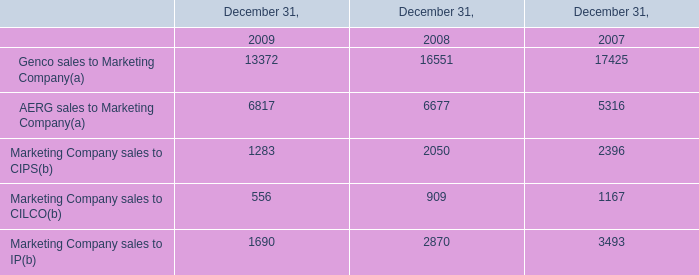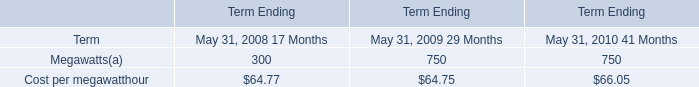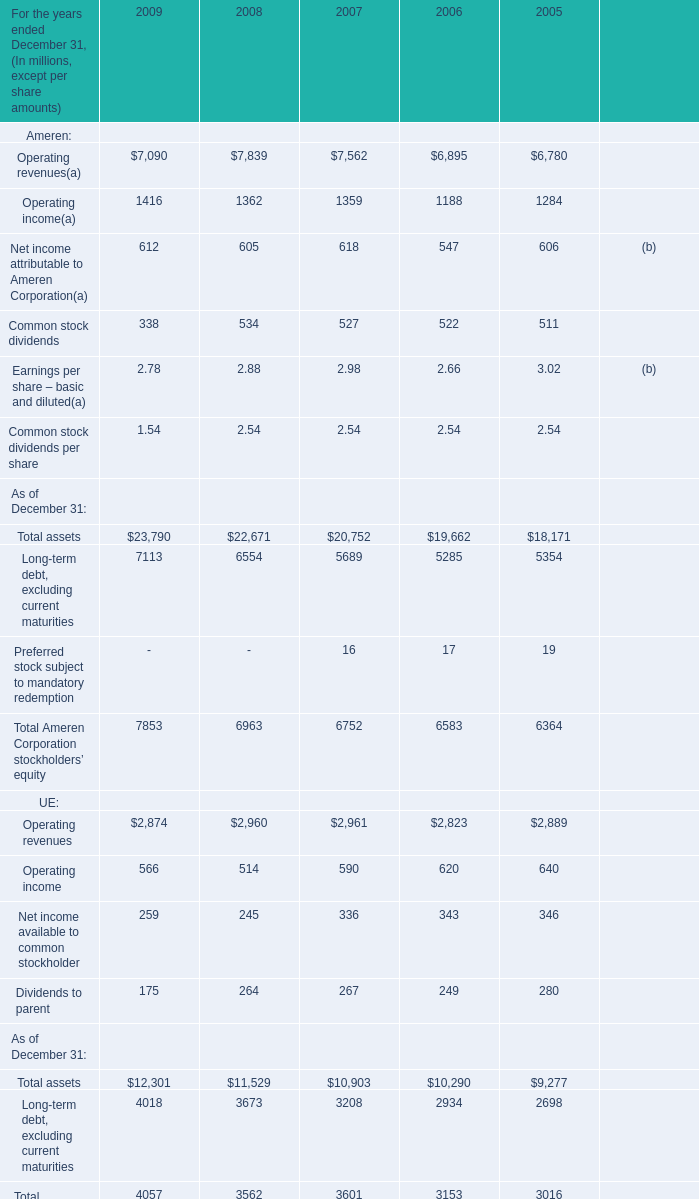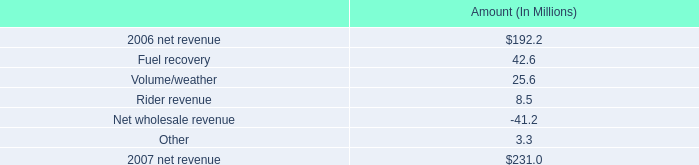What is the average amount of Operating income of 2007, and Marketing Company sales to IP of December 31, 2008 ? 
Computations: ((1359.0 + 2870.0) / 2)
Answer: 2114.5. 